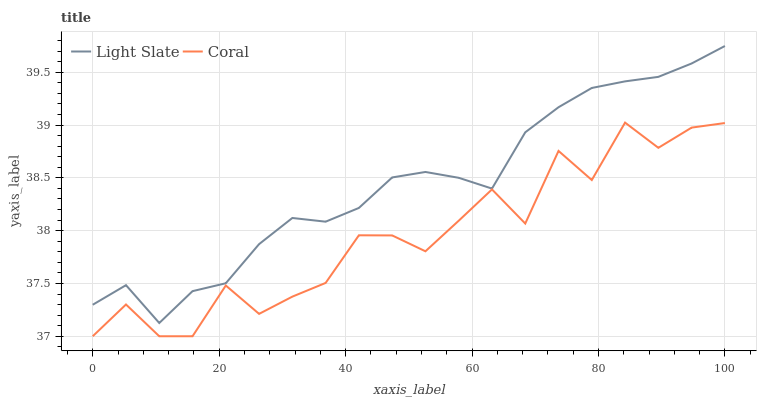Does Coral have the minimum area under the curve?
Answer yes or no. Yes. Does Light Slate have the maximum area under the curve?
Answer yes or no. Yes. Does Coral have the maximum area under the curve?
Answer yes or no. No. Is Light Slate the smoothest?
Answer yes or no. Yes. Is Coral the roughest?
Answer yes or no. Yes. Is Coral the smoothest?
Answer yes or no. No. Does Coral have the lowest value?
Answer yes or no. Yes. Does Light Slate have the highest value?
Answer yes or no. Yes. Does Coral have the highest value?
Answer yes or no. No. Is Coral less than Light Slate?
Answer yes or no. Yes. Is Light Slate greater than Coral?
Answer yes or no. Yes. Does Coral intersect Light Slate?
Answer yes or no. No. 